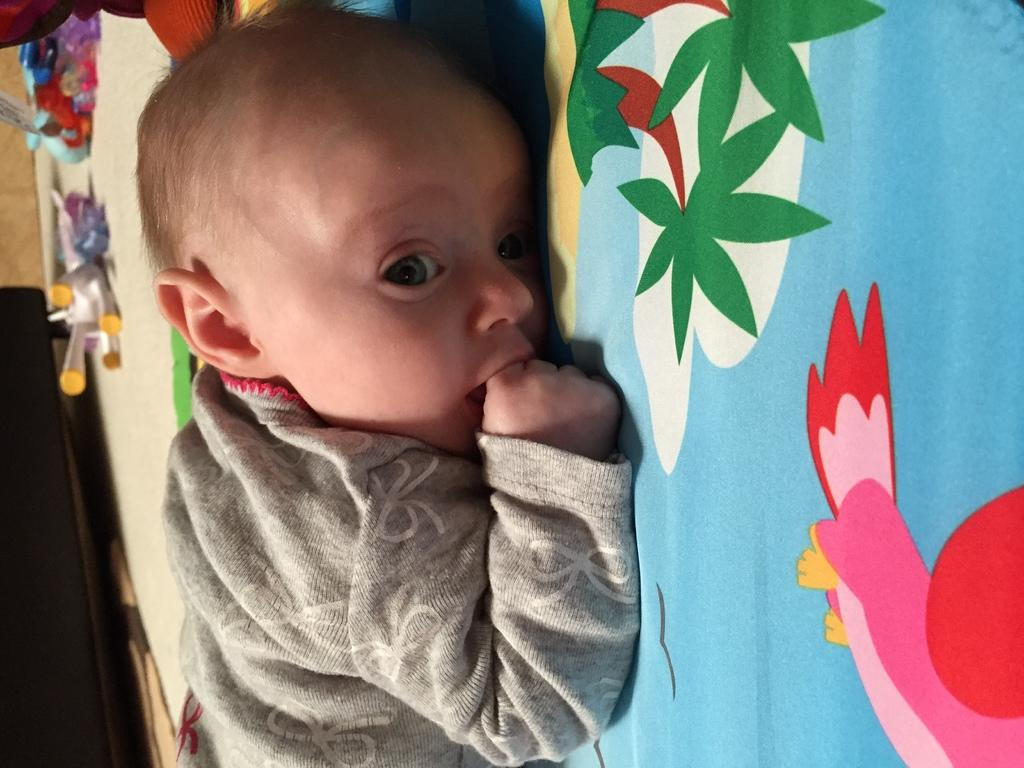What is the main subject of the image? There is a baby in the image. Where is the baby located? The baby is laying on a bed. What can be seen on the bed sheet? There are cartoon images on the bed sheet. What is present on the left side of the image? There are toys on the left side of the image. What type of teaching is the baby receiving in the image? There is no indication of teaching in the image; it simply shows a baby laying on a bed with toys nearby. 